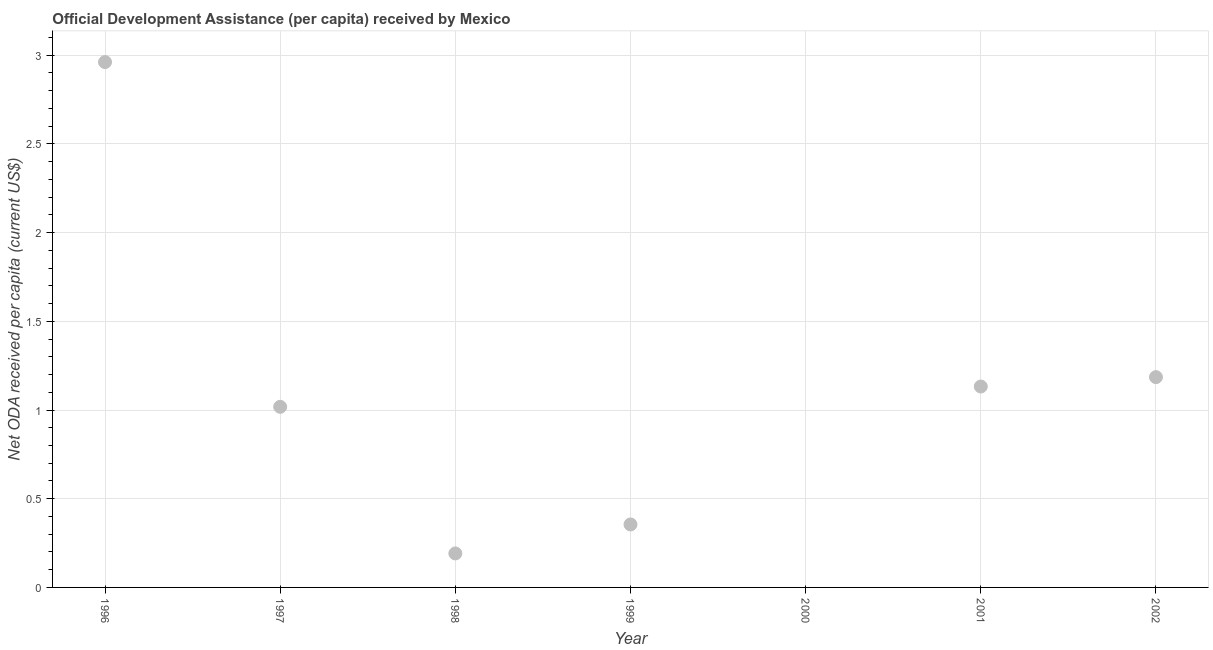Across all years, what is the maximum net oda received per capita?
Offer a very short reply. 2.96. What is the sum of the net oda received per capita?
Offer a terse response. 6.84. What is the difference between the net oda received per capita in 1996 and 1999?
Make the answer very short. 2.61. What is the average net oda received per capita per year?
Your answer should be compact. 0.98. What is the median net oda received per capita?
Keep it short and to the point. 1.02. In how many years, is the net oda received per capita greater than 1.9 US$?
Give a very brief answer. 1. What is the ratio of the net oda received per capita in 1997 to that in 1999?
Offer a very short reply. 2.87. What is the difference between the highest and the second highest net oda received per capita?
Your answer should be compact. 1.78. Is the sum of the net oda received per capita in 1998 and 2002 greater than the maximum net oda received per capita across all years?
Give a very brief answer. No. What is the difference between the highest and the lowest net oda received per capita?
Ensure brevity in your answer.  2.96. In how many years, is the net oda received per capita greater than the average net oda received per capita taken over all years?
Your response must be concise. 4. Does the net oda received per capita monotonically increase over the years?
Offer a very short reply. No. Are the values on the major ticks of Y-axis written in scientific E-notation?
Ensure brevity in your answer.  No. Does the graph contain grids?
Offer a very short reply. Yes. What is the title of the graph?
Give a very brief answer. Official Development Assistance (per capita) received by Mexico. What is the label or title of the X-axis?
Ensure brevity in your answer.  Year. What is the label or title of the Y-axis?
Keep it short and to the point. Net ODA received per capita (current US$). What is the Net ODA received per capita (current US$) in 1996?
Your answer should be very brief. 2.96. What is the Net ODA received per capita (current US$) in 1997?
Offer a terse response. 1.02. What is the Net ODA received per capita (current US$) in 1998?
Make the answer very short. 0.19. What is the Net ODA received per capita (current US$) in 1999?
Keep it short and to the point. 0.36. What is the Net ODA received per capita (current US$) in 2001?
Your answer should be compact. 1.13. What is the Net ODA received per capita (current US$) in 2002?
Ensure brevity in your answer.  1.19. What is the difference between the Net ODA received per capita (current US$) in 1996 and 1997?
Your response must be concise. 1.94. What is the difference between the Net ODA received per capita (current US$) in 1996 and 1998?
Provide a short and direct response. 2.77. What is the difference between the Net ODA received per capita (current US$) in 1996 and 1999?
Your answer should be compact. 2.61. What is the difference between the Net ODA received per capita (current US$) in 1996 and 2001?
Keep it short and to the point. 1.83. What is the difference between the Net ODA received per capita (current US$) in 1996 and 2002?
Your answer should be very brief. 1.78. What is the difference between the Net ODA received per capita (current US$) in 1997 and 1998?
Offer a terse response. 0.83. What is the difference between the Net ODA received per capita (current US$) in 1997 and 1999?
Keep it short and to the point. 0.66. What is the difference between the Net ODA received per capita (current US$) in 1997 and 2001?
Make the answer very short. -0.11. What is the difference between the Net ODA received per capita (current US$) in 1997 and 2002?
Make the answer very short. -0.17. What is the difference between the Net ODA received per capita (current US$) in 1998 and 1999?
Ensure brevity in your answer.  -0.16. What is the difference between the Net ODA received per capita (current US$) in 1998 and 2001?
Provide a short and direct response. -0.94. What is the difference between the Net ODA received per capita (current US$) in 1998 and 2002?
Give a very brief answer. -0.99. What is the difference between the Net ODA received per capita (current US$) in 1999 and 2001?
Your answer should be very brief. -0.78. What is the difference between the Net ODA received per capita (current US$) in 1999 and 2002?
Keep it short and to the point. -0.83. What is the difference between the Net ODA received per capita (current US$) in 2001 and 2002?
Ensure brevity in your answer.  -0.05. What is the ratio of the Net ODA received per capita (current US$) in 1996 to that in 1997?
Keep it short and to the point. 2.91. What is the ratio of the Net ODA received per capita (current US$) in 1996 to that in 1998?
Provide a short and direct response. 15.45. What is the ratio of the Net ODA received per capita (current US$) in 1996 to that in 1999?
Offer a very short reply. 8.34. What is the ratio of the Net ODA received per capita (current US$) in 1996 to that in 2001?
Make the answer very short. 2.62. What is the ratio of the Net ODA received per capita (current US$) in 1996 to that in 2002?
Your answer should be very brief. 2.5. What is the ratio of the Net ODA received per capita (current US$) in 1997 to that in 1998?
Keep it short and to the point. 5.31. What is the ratio of the Net ODA received per capita (current US$) in 1997 to that in 1999?
Your answer should be very brief. 2.87. What is the ratio of the Net ODA received per capita (current US$) in 1997 to that in 2001?
Provide a succinct answer. 0.9. What is the ratio of the Net ODA received per capita (current US$) in 1997 to that in 2002?
Your answer should be compact. 0.86. What is the ratio of the Net ODA received per capita (current US$) in 1998 to that in 1999?
Provide a short and direct response. 0.54. What is the ratio of the Net ODA received per capita (current US$) in 1998 to that in 2001?
Provide a succinct answer. 0.17. What is the ratio of the Net ODA received per capita (current US$) in 1998 to that in 2002?
Offer a very short reply. 0.16. What is the ratio of the Net ODA received per capita (current US$) in 1999 to that in 2001?
Your answer should be compact. 0.31. What is the ratio of the Net ODA received per capita (current US$) in 1999 to that in 2002?
Give a very brief answer. 0.3. What is the ratio of the Net ODA received per capita (current US$) in 2001 to that in 2002?
Ensure brevity in your answer.  0.95. 